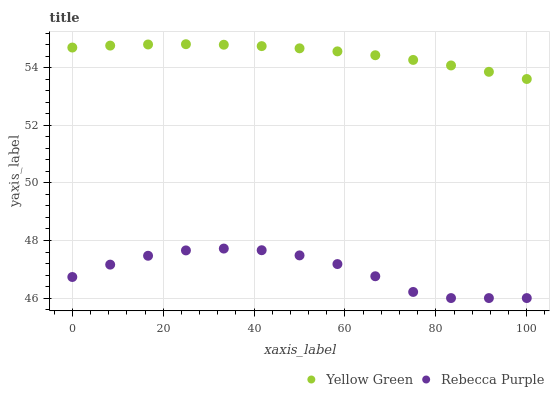Does Rebecca Purple have the minimum area under the curve?
Answer yes or no. Yes. Does Yellow Green have the maximum area under the curve?
Answer yes or no. Yes. Does Rebecca Purple have the maximum area under the curve?
Answer yes or no. No. Is Yellow Green the smoothest?
Answer yes or no. Yes. Is Rebecca Purple the roughest?
Answer yes or no. Yes. Is Rebecca Purple the smoothest?
Answer yes or no. No. Does Rebecca Purple have the lowest value?
Answer yes or no. Yes. Does Yellow Green have the highest value?
Answer yes or no. Yes. Does Rebecca Purple have the highest value?
Answer yes or no. No. Is Rebecca Purple less than Yellow Green?
Answer yes or no. Yes. Is Yellow Green greater than Rebecca Purple?
Answer yes or no. Yes. Does Rebecca Purple intersect Yellow Green?
Answer yes or no. No. 